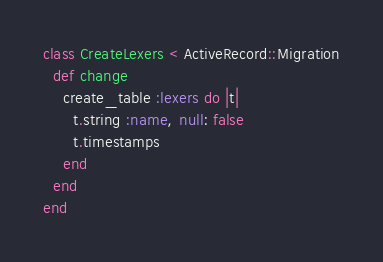<code> <loc_0><loc_0><loc_500><loc_500><_Ruby_>class CreateLexers < ActiveRecord::Migration
  def change
    create_table :lexers do |t|
      t.string :name, null: false
      t.timestamps
    end
  end
end
</code> 